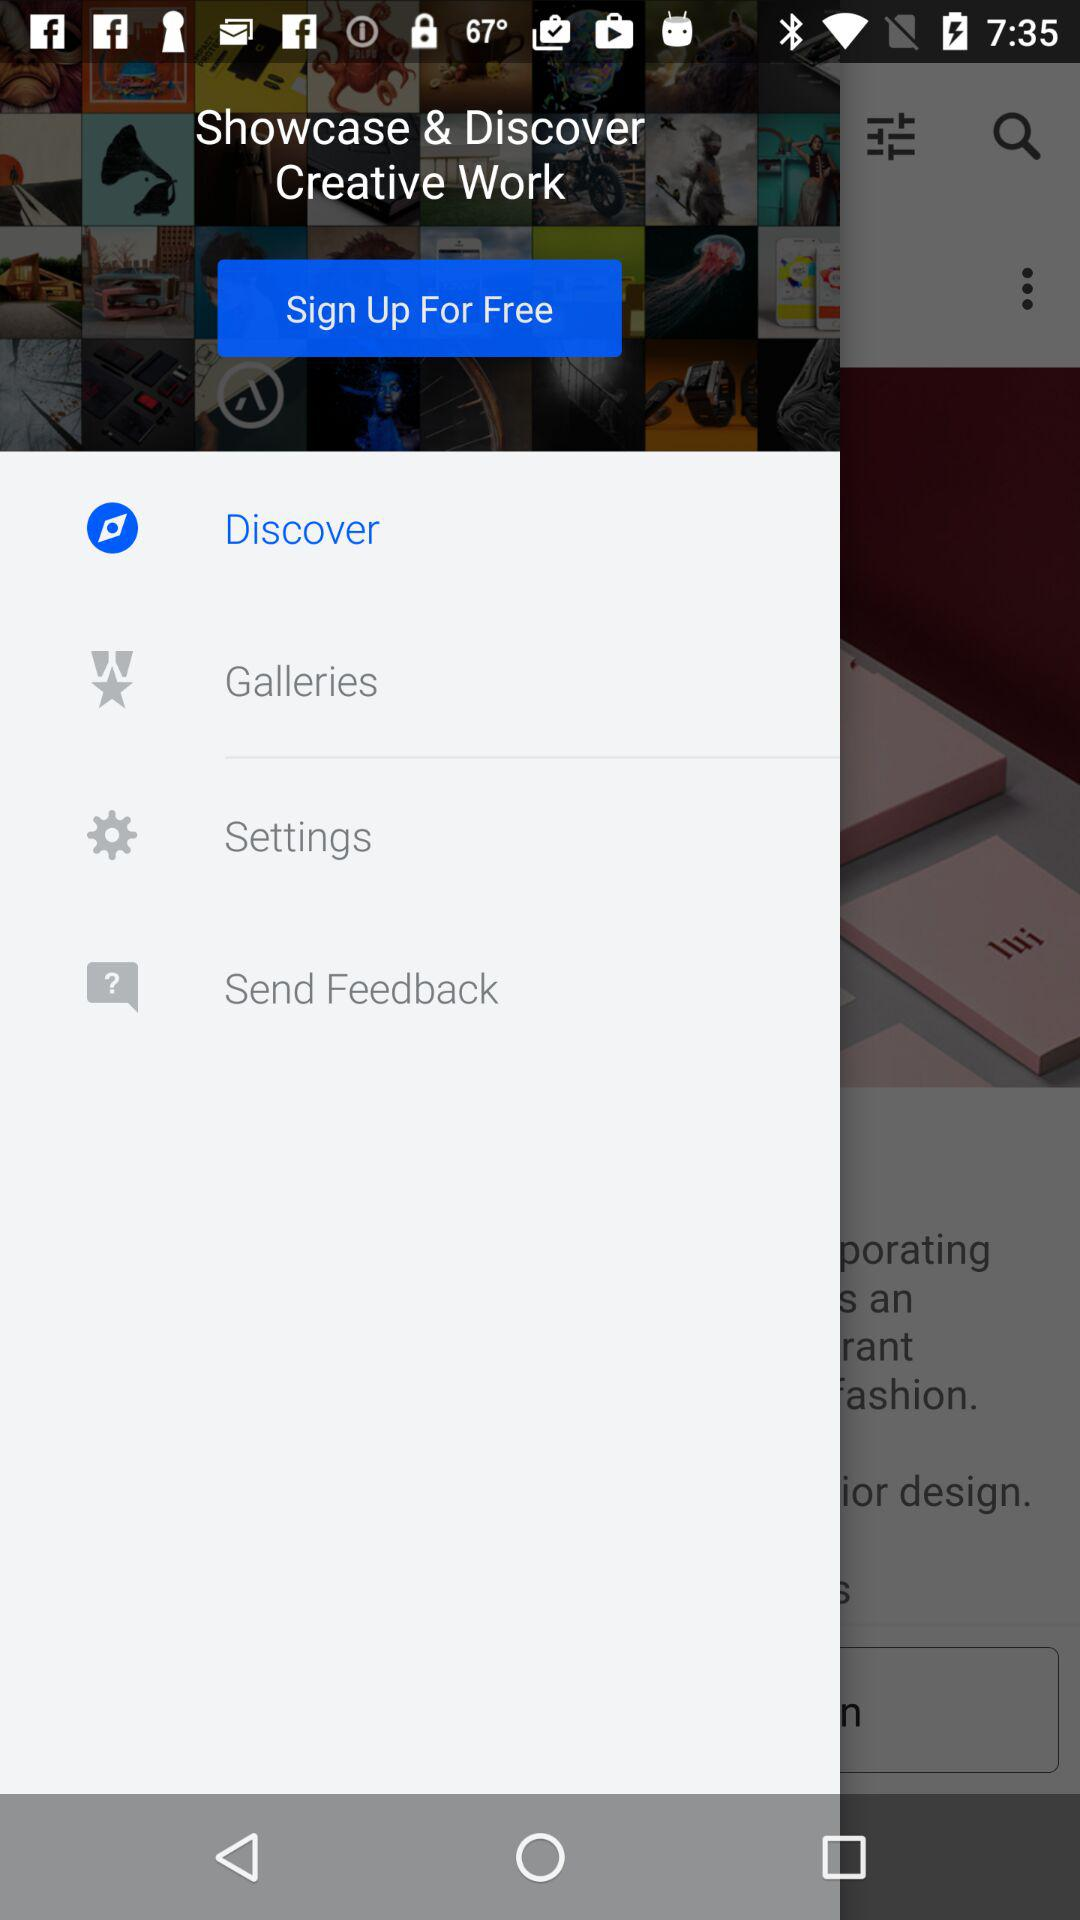Which tab has selected? The selected tab is "Discover". 